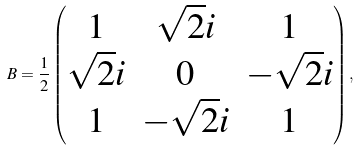<formula> <loc_0><loc_0><loc_500><loc_500>B = \frac { 1 } { 2 } \begin{pmatrix} 1 & \sqrt { 2 } i & 1 \\ \sqrt { 2 } i & 0 & - \sqrt { 2 } i \\ 1 & - \sqrt { 2 } i & 1 \end{pmatrix} ,</formula> 